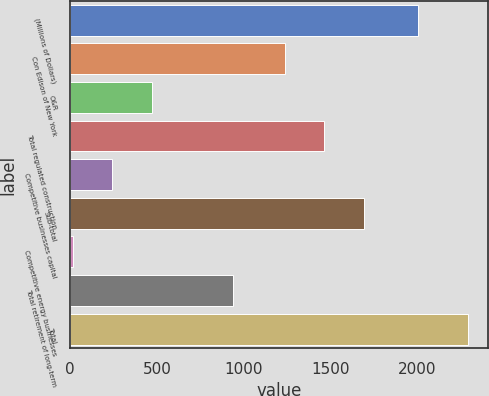<chart> <loc_0><loc_0><loc_500><loc_500><bar_chart><fcel>(Millions of Dollars)<fcel>Con Edison of New York<fcel>O&R<fcel>Total regulated construction<fcel>Competitive businesses capital<fcel>Sub-total<fcel>Competitive energy businesses<fcel>Total retirement of long-term<fcel>Total<nl><fcel>2004<fcel>1235<fcel>471<fcel>1462.5<fcel>243.5<fcel>1690<fcel>16<fcel>939<fcel>2291<nl></chart> 